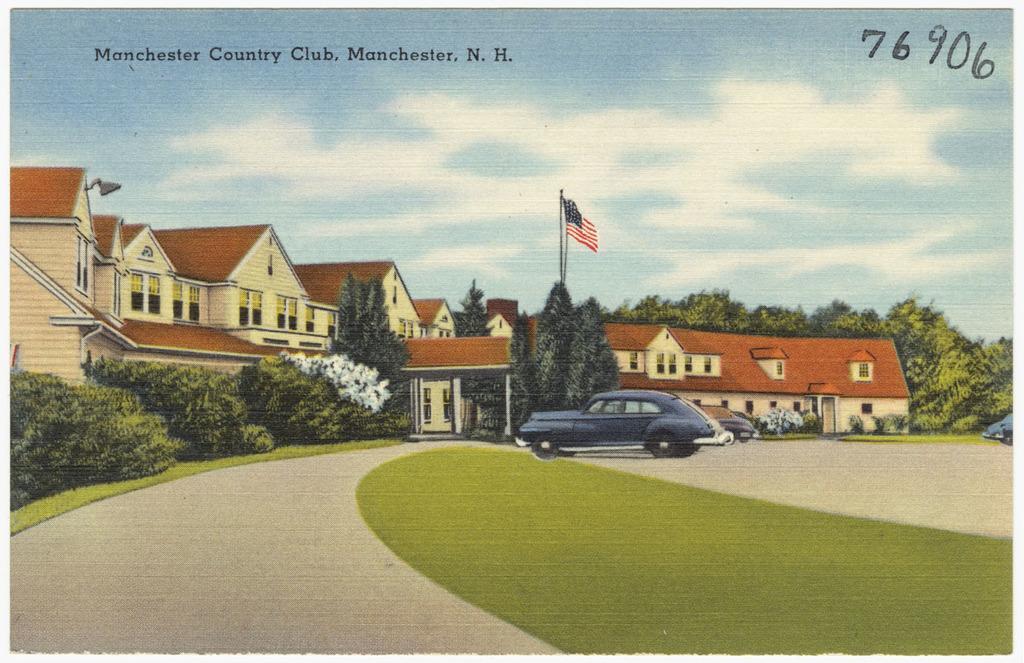Could you give a brief overview of what you see in this image? This image is an depiction. In this image we can see the roof houses, trees, vehicles, grass, path and also the sky with the clouds. We can also see the text and also the numbers and a flag. 